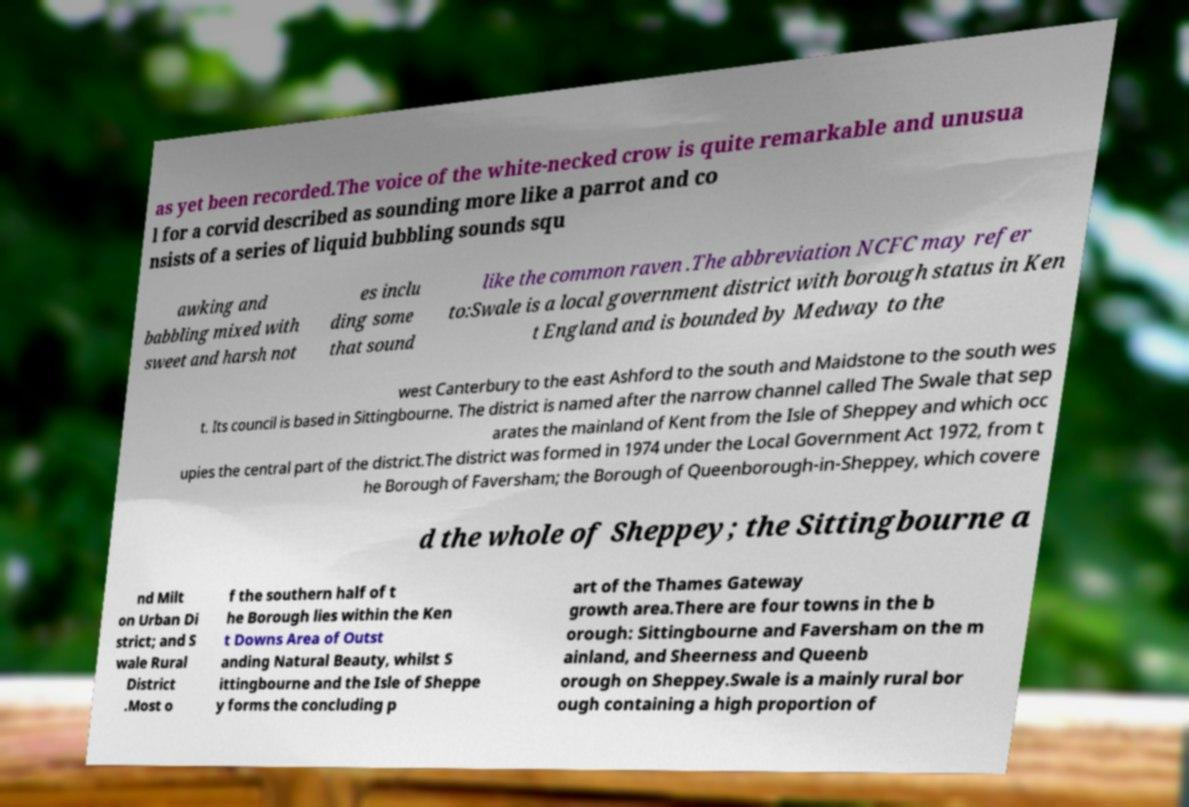I need the written content from this picture converted into text. Can you do that? as yet been recorded.The voice of the white-necked crow is quite remarkable and unusua l for a corvid described as sounding more like a parrot and co nsists of a series of liquid bubbling sounds squ awking and babbling mixed with sweet and harsh not es inclu ding some that sound like the common raven .The abbreviation NCFC may refer to:Swale is a local government district with borough status in Ken t England and is bounded by Medway to the west Canterbury to the east Ashford to the south and Maidstone to the south wes t. Its council is based in Sittingbourne. The district is named after the narrow channel called The Swale that sep arates the mainland of Kent from the Isle of Sheppey and which occ upies the central part of the district.The district was formed in 1974 under the Local Government Act 1972, from t he Borough of Faversham; the Borough of Queenborough-in-Sheppey, which covere d the whole of Sheppey; the Sittingbourne a nd Milt on Urban Di strict; and S wale Rural District .Most o f the southern half of t he Borough lies within the Ken t Downs Area of Outst anding Natural Beauty, whilst S ittingbourne and the Isle of Sheppe y forms the concluding p art of the Thames Gateway growth area.There are four towns in the b orough: Sittingbourne and Faversham on the m ainland, and Sheerness and Queenb orough on Sheppey.Swale is a mainly rural bor ough containing a high proportion of 